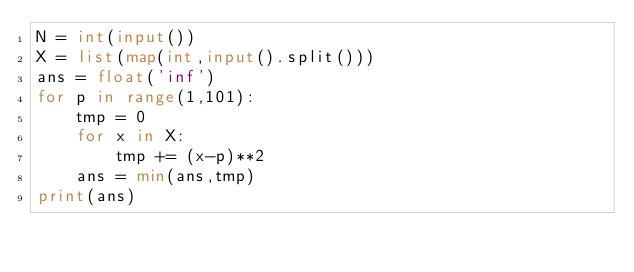Convert code to text. <code><loc_0><loc_0><loc_500><loc_500><_Python_>N = int(input())
X = list(map(int,input().split()))
ans = float('inf')
for p in range(1,101):
    tmp = 0
    for x in X:
        tmp += (x-p)**2
    ans = min(ans,tmp)
print(ans)</code> 